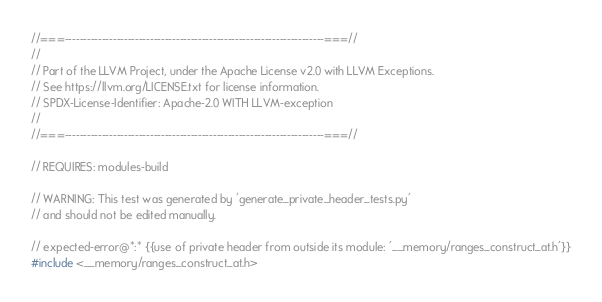<code> <loc_0><loc_0><loc_500><loc_500><_C++_>//===----------------------------------------------------------------------===//
//
// Part of the LLVM Project, under the Apache License v2.0 with LLVM Exceptions.
// See https://llvm.org/LICENSE.txt for license information.
// SPDX-License-Identifier: Apache-2.0 WITH LLVM-exception
//
//===----------------------------------------------------------------------===//

// REQUIRES: modules-build

// WARNING: This test was generated by 'generate_private_header_tests.py'
// and should not be edited manually.

// expected-error@*:* {{use of private header from outside its module: '__memory/ranges_construct_at.h'}}
#include <__memory/ranges_construct_at.h>
</code> 